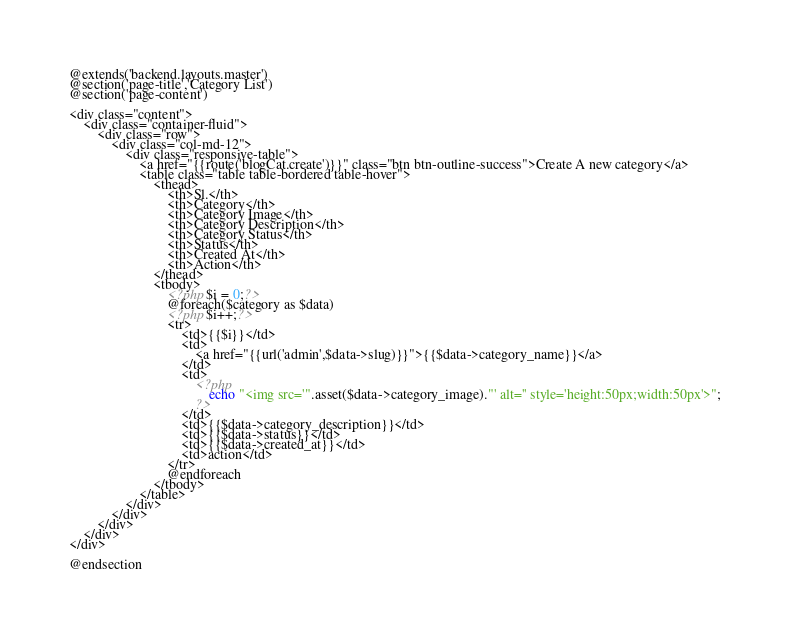Convert code to text. <code><loc_0><loc_0><loc_500><loc_500><_PHP_>@extends('backend.layouts.master')
@section('page-title','Category List')
@section('page-content')

<div class="content">
	<div class="container-fluid">
		<div class="row">
			<div class="col-md-12">
				<div class="responsive-table">
					<a href="{{route('blogCat.create')}}" class="btn btn-outline-success">Create A new category</a>
					<table class="table table-bordered table-hover">
						<thead> 
							<th>Sl.</th>
							<th>Category</th>
							<th>Category Image</th>
							<th>Category Description</th>
							<th>Category Status</th>
							<th>Status</th>
							<th>Created At</th>
							<th>Action</th>
						</thead>
						<tbody>
							<?php $i = 0;?>
							@foreach($category as $data)
							<?php $i++;?>
							<tr>
								<td>{{$i}}</td>
								<td> 
									<a href="{{url('admin',$data->slug)}}">{{$data->category_name}}</a>
								</td>
								<td>
									<?php
										echo "<img src='".asset($data->category_image)."' alt='' style='height:50px;width:50px'>";
									?>
								</td>
								<td>{{$data->category_description}}</td>
								<td>{{$data->status}}</td>
								<td>{{$data->created_at}}</td>
								<td>action</td>
							</tr>
							@endforeach
						</tbody>
					</table>
				</div>
			</div>
		</div>
	</div>
</div>

@endsection</code> 